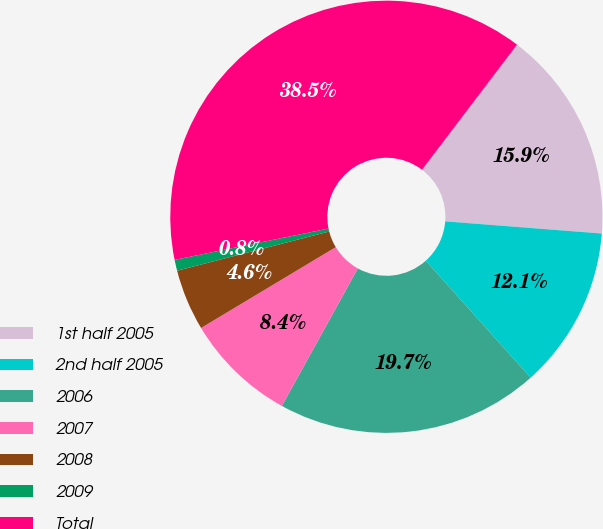Convert chart to OTSL. <chart><loc_0><loc_0><loc_500><loc_500><pie_chart><fcel>1st half 2005<fcel>2nd half 2005<fcel>2006<fcel>2007<fcel>2008<fcel>2009<fcel>Total<nl><fcel>15.9%<fcel>12.13%<fcel>19.67%<fcel>8.36%<fcel>4.59%<fcel>0.82%<fcel>38.53%<nl></chart> 